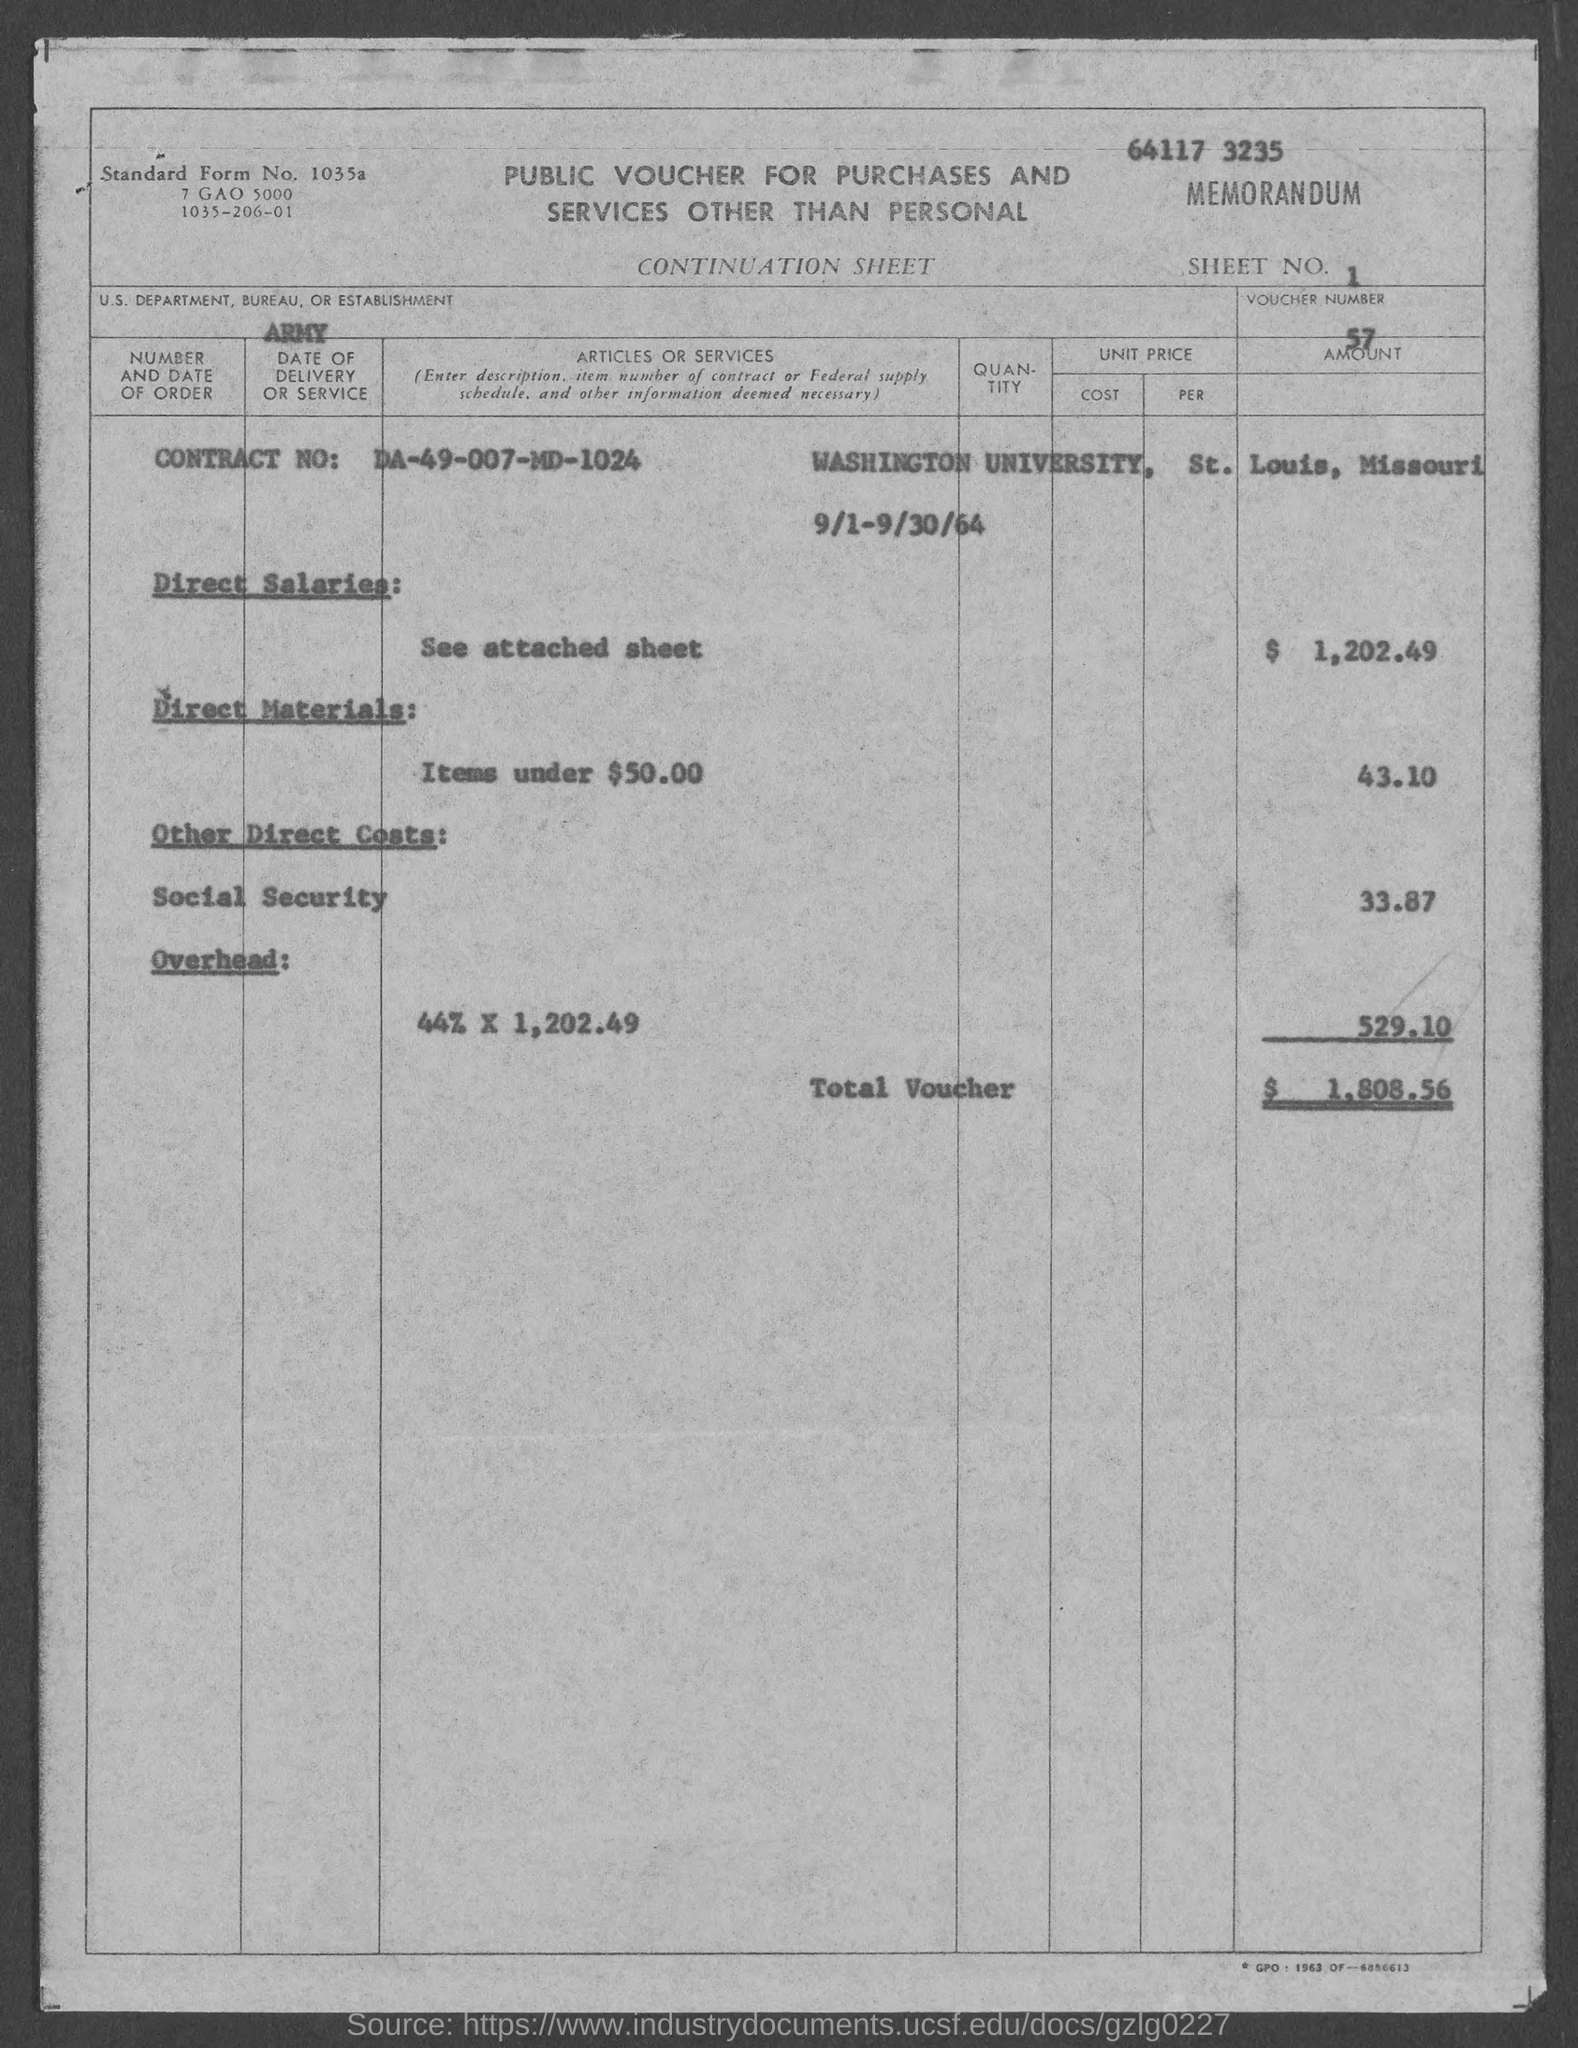What is the sheet no.?
Offer a terse response. 1. What is the voucher number ?
Ensure brevity in your answer.  57. What is the us. department, bureau, or establishment in voucher?
Keep it short and to the point. Army. What is the contract number ?
Offer a terse response. DA-49-007-MD-1024. What is the total voucher amount ?
Keep it short and to the point. $1,808.56. What is the direct salaries amount in voucher ?
Provide a short and direct response. $1,202.49. 